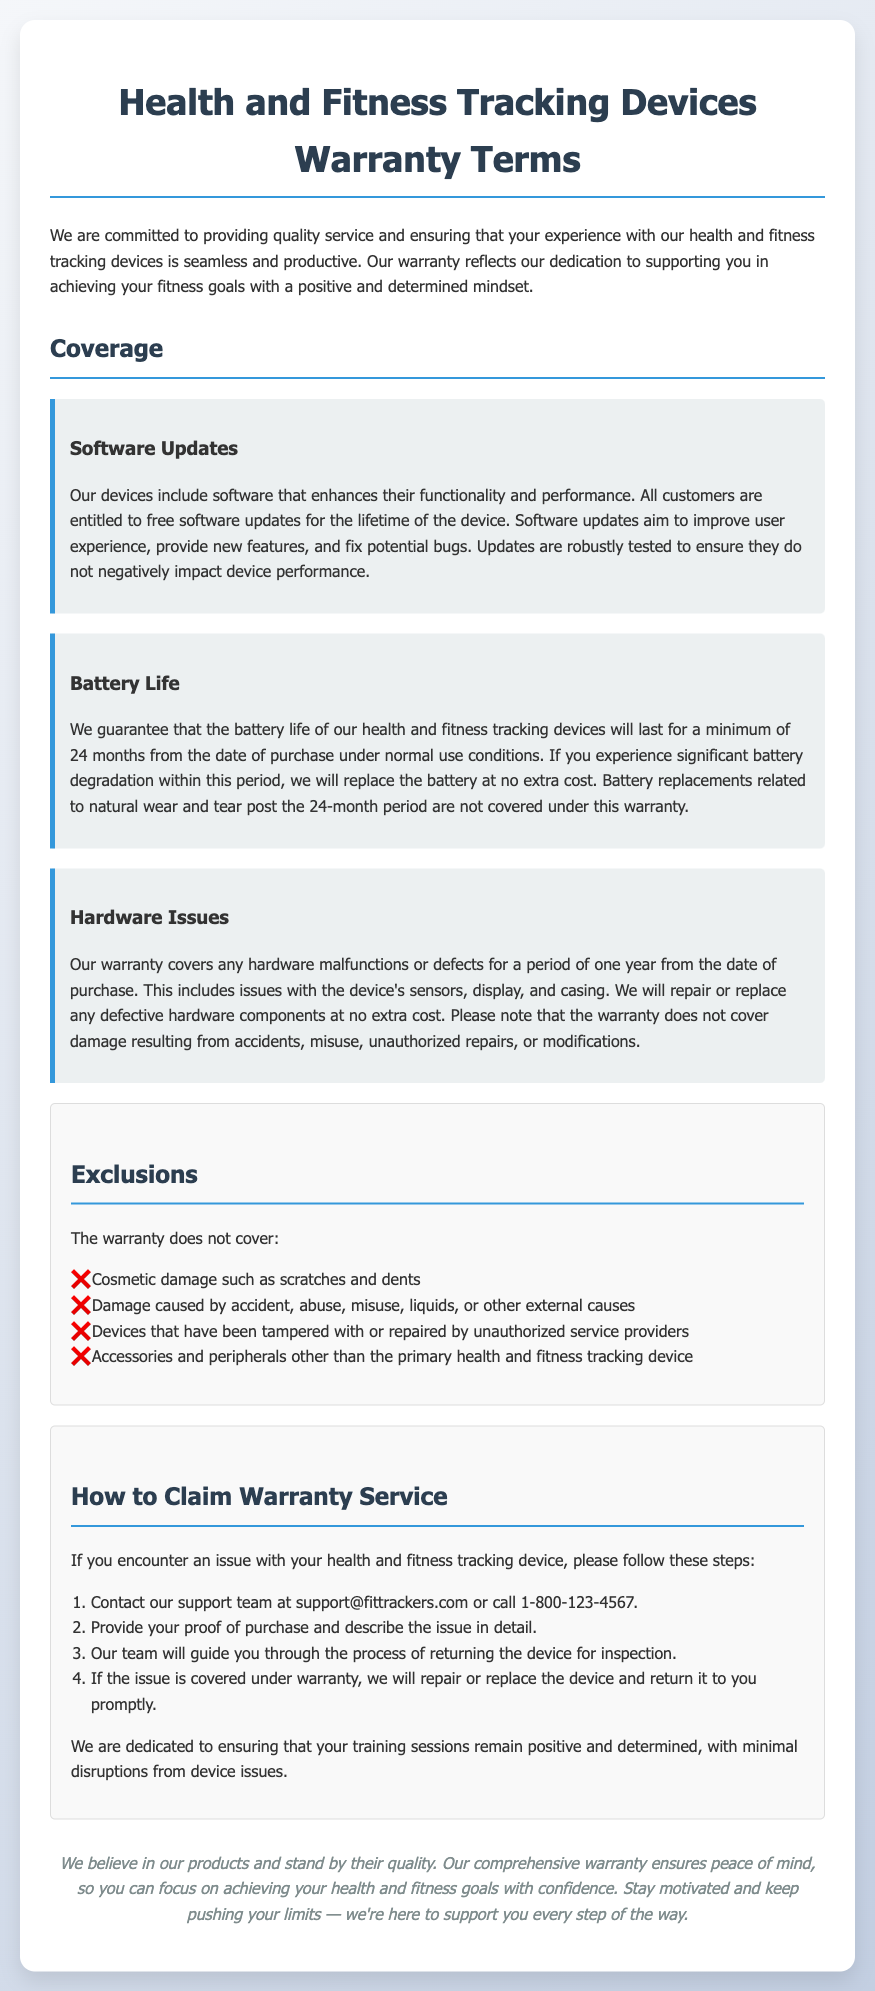What is the minimum battery life guarantee? The document states that the battery life is guaranteed to last for a minimum of 24 months from the date of purchase under normal use conditions.
Answer: 24 months How long is hardware issue coverage? It mentions that the warranty covers hardware malfunctions or defects for a period of one year from the date of purchase.
Answer: One year Is software update free? The document confirms that all customers are entitled to free software updates for the lifetime of the device.
Answer: Yes What should you provide when claiming warranty service? The document specifies that you should provide your proof of purchase and describe the issue in detail when claiming warranty service.
Answer: Proof of purchase What kind of damage is not covered under the warranty? The document lists cosmetic damage such as scratches and dents as an example of damage not covered under the warranty.
Answer: Cosmetic damage How can you contact support for warranty claims? The document states that you can contact the support team at support@fittrackers.com or call 1-800-123-4567 for warranty claims.
Answer: support@fittrackers.com What type of device issues does the warranty cover? The warranty covers issues with the device's sensors, display, and casing under hardware issues.
Answer: Sensors, display, casing What is the warranty duration for battery replacements? The document explains that battery replacements related to natural wear and tear post the 24-month period are not covered under this warranty.
Answer: 24 months What will happen if an issue is covered under warranty? The document indicates that if the issue is covered under warranty, they will repair or replace the device and return it to you promptly.
Answer: Repair or replace the device 